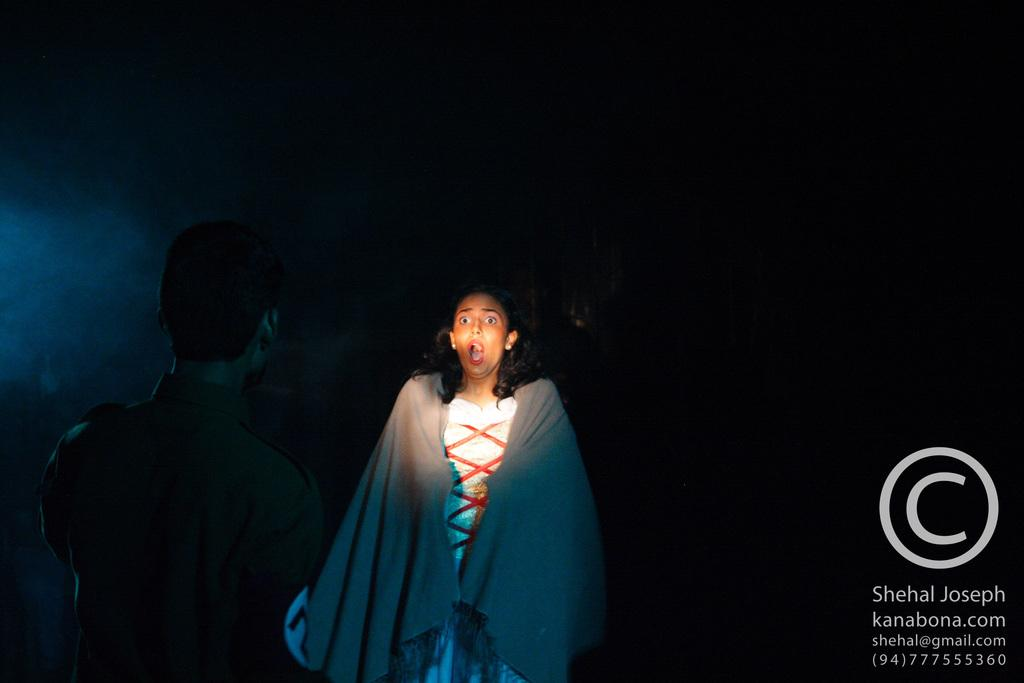What is the main subject of the image? There is a girl standing in the image. Can you describe any text visible in the image? There is written text on the right side of the image. What type of oatmeal is the girl eating in the image? There is no oatmeal present in the image, and the girl is not eating anything. What is the plot of the story depicted in the image? There is no story depicted in the image, as it is a simple photograph of a girl standing and written text on the right side. 